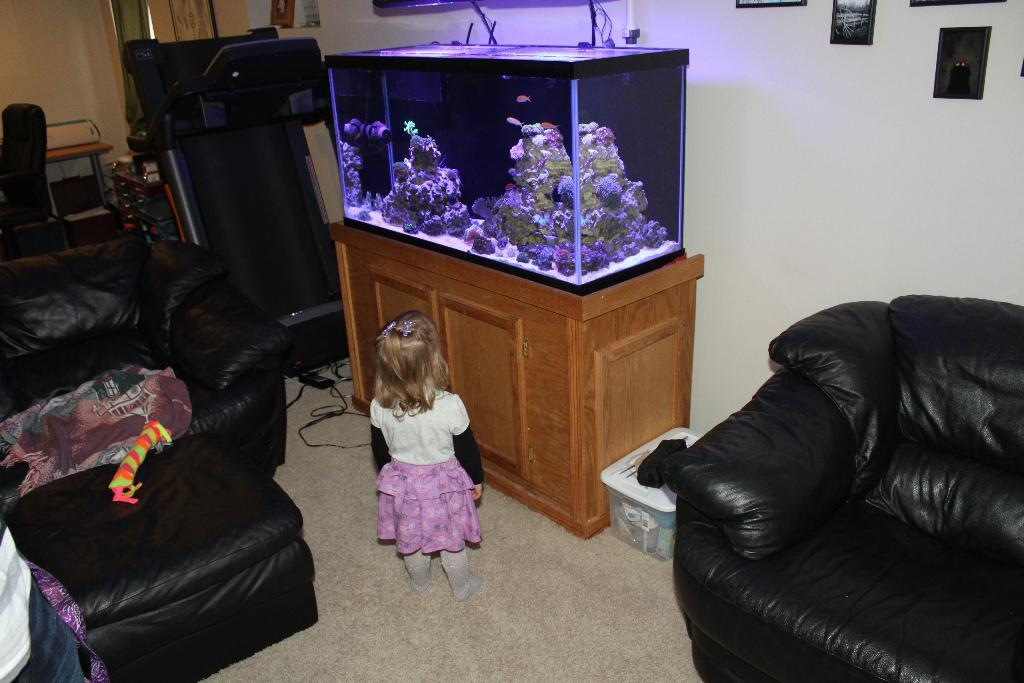Who is present in the image? There is a woman in the image. What is the woman standing in front of? The woman is standing in front of an aquarium. What type of furniture is visible in the image? There is a sofa and a chair in the image. What book is the woman holding in her throat in the image? There is no book present in the image, and the woman is not holding anything in her throat. 